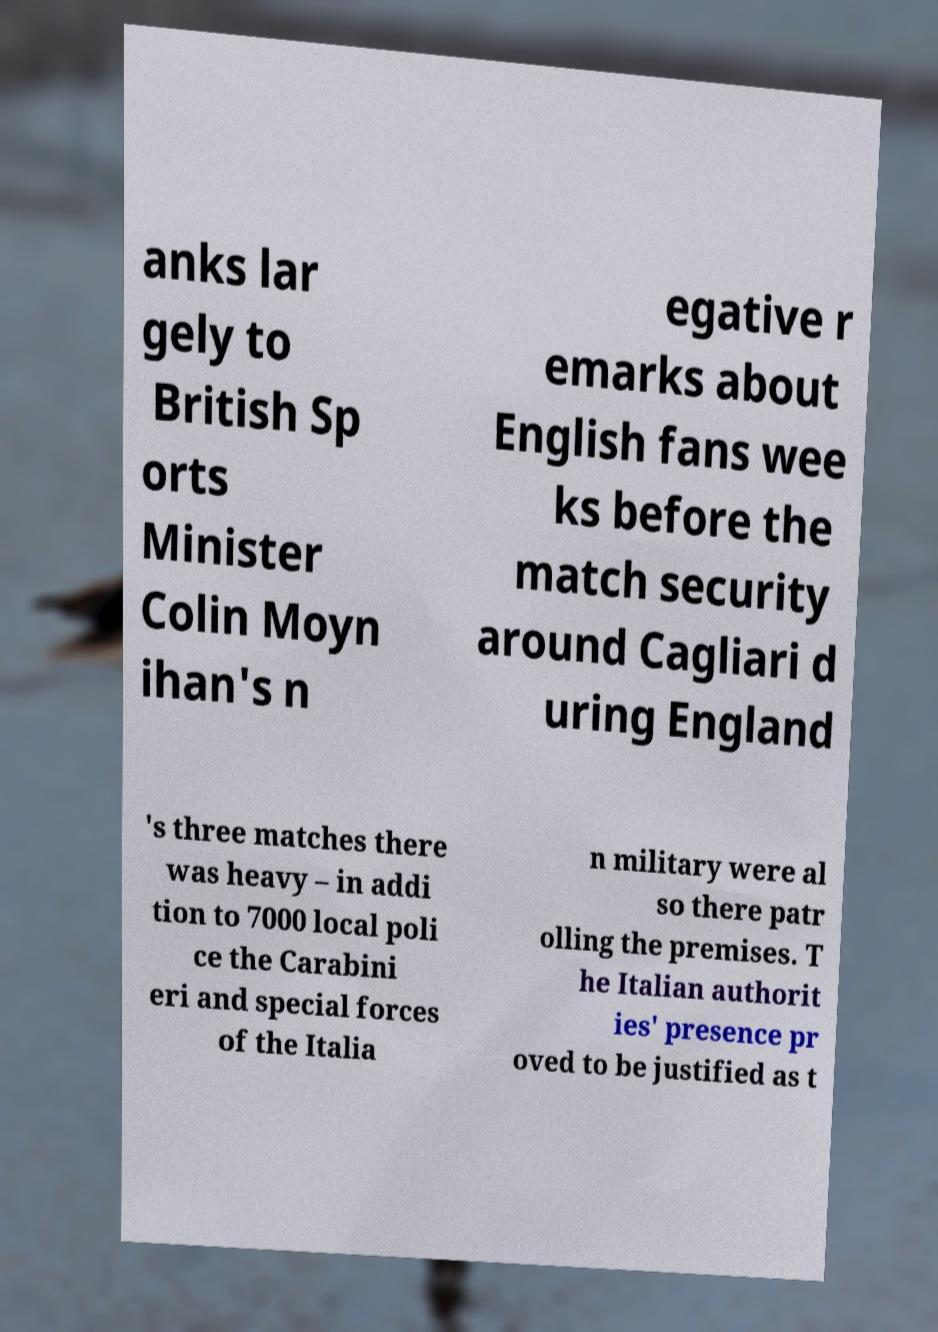Can you read and provide the text displayed in the image?This photo seems to have some interesting text. Can you extract and type it out for me? anks lar gely to British Sp orts Minister Colin Moyn ihan's n egative r emarks about English fans wee ks before the match security around Cagliari d uring England 's three matches there was heavy – in addi tion to 7000 local poli ce the Carabini eri and special forces of the Italia n military were al so there patr olling the premises. T he Italian authorit ies' presence pr oved to be justified as t 